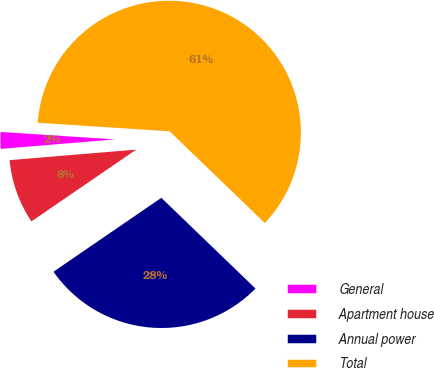<chart> <loc_0><loc_0><loc_500><loc_500><pie_chart><fcel>General<fcel>Apartment house<fcel>Annual power<fcel>Total<nl><fcel>2.35%<fcel>8.24%<fcel>28.24%<fcel>61.18%<nl></chart> 